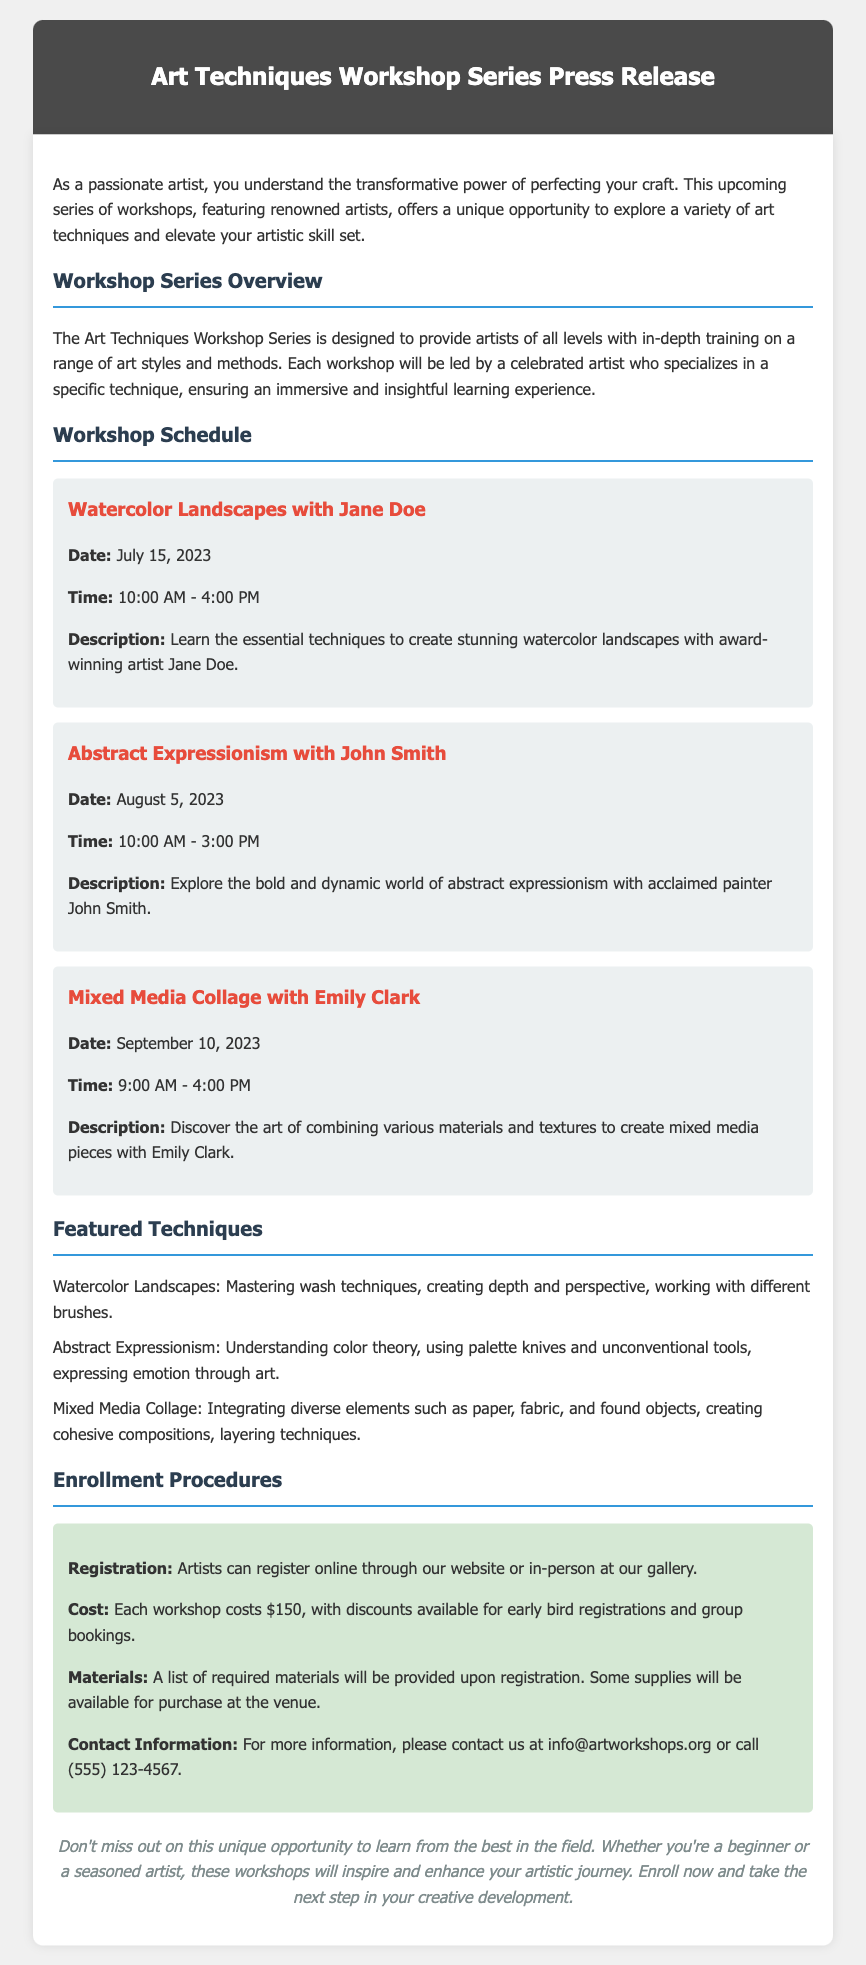What is the title of the workshop series? The title of the workshop series is mentioned in the header of the document.
Answer: Art Techniques Workshop Series Press Release Who will be leading the workshop on Abstract Expressionism? The name of the artist leading the workshop on Abstract Expressionism is specified under the workshop schedule.
Answer: John Smith What is the date for the Mixed Media Collage workshop? The date for the Mixed Media Collage workshop is provided in the workshop details section.
Answer: September 10, 2023 How much does each workshop cost? The cost of the workshops is listed under the enrollment procedures.
Answer: $150 What technique will be taught in Jane Doe's workshop? The technique taught in Jane Doe's workshop is specified in the workshop details.
Answer: Watercolor Landscapes How long is the workshop on Abstract Expressionism? The duration of the workshop on Abstract Expressionism can be found in the schedule.
Answer: 5 hours What type of materials will be provided upon registration? The details about materials are mentioned in the enrollment procedures section.
Answer: Required materials list What benefits are mentioned for early bird registrations? The benefits of early bird registrations concern discounts, which are mentioned under the enrollment procedures.
Answer: Discounts available Is it possible to register in-person? The registration options are outlined in the enrollment procedures section of the document.
Answer: Yes 